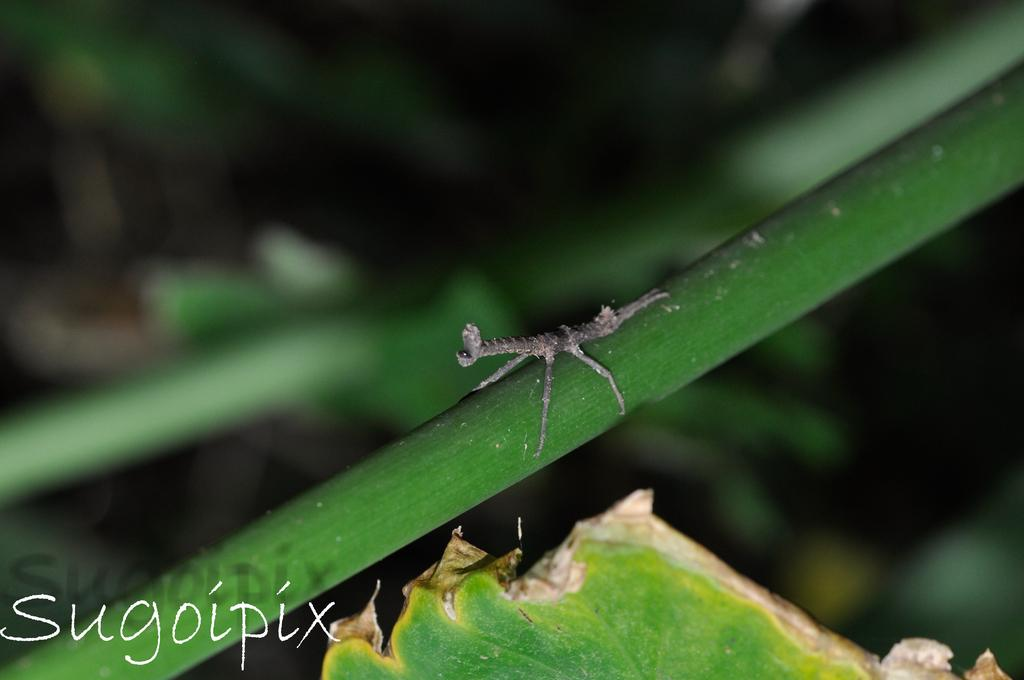What is present on the stem in the image? There is an insect on the stem in the image. What else can be seen in the image besides the insect? There is a leaf in the image. How would you describe the background of the image? The background of the image is blurred. Is there any additional information or marking in the image? Yes, there is a watermark in the bottom right corner of the image. What advice does the scarecrow give to the insect in the image? There is no scarecrow present in the image, so it is not possible to answer that question. 